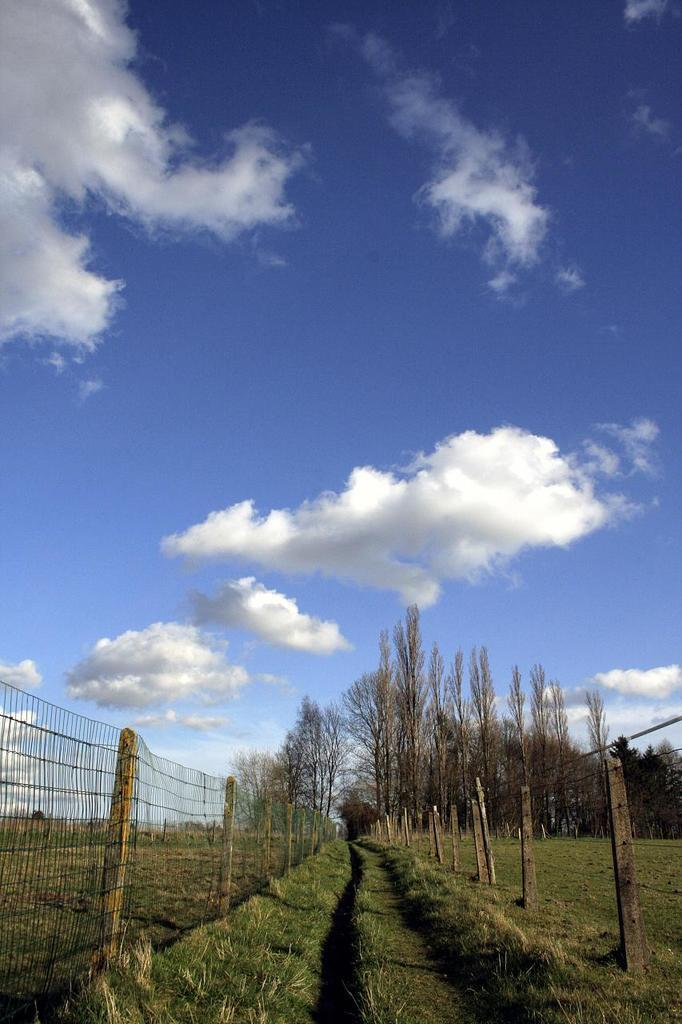What type of vegetation can be seen in the image? There are dry trees in the image. What else can be seen growing in the image? There is grass in the image. What type of barrier is present in the image? There is fencing in the image. What is the color of the sky in the image? The sky is blue and white in color. Can you tell me where the mother is in the image? There is no mother present in the image. What type of jewelry can be seen on the dry trees in the image? There is no jewelry, such as a locket, present on the dry trees in the image. 